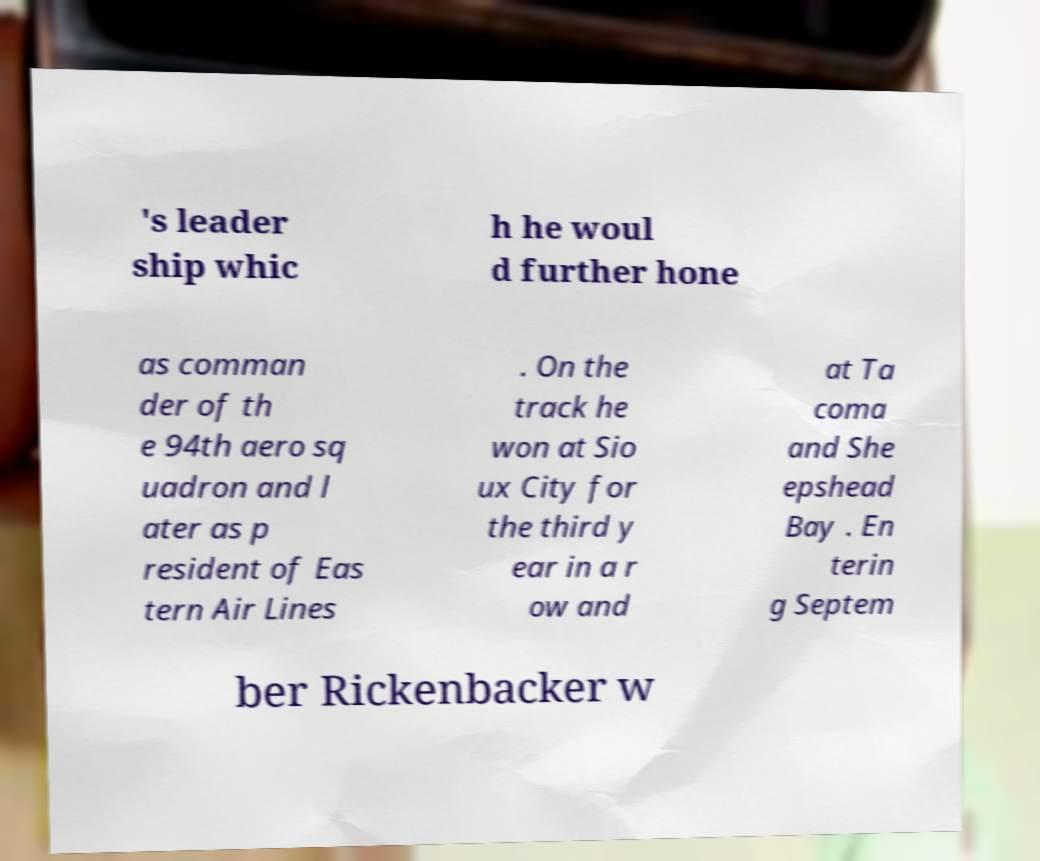For documentation purposes, I need the text within this image transcribed. Could you provide that? 's leader ship whic h he woul d further hone as comman der of th e 94th aero sq uadron and l ater as p resident of Eas tern Air Lines . On the track he won at Sio ux City for the third y ear in a r ow and at Ta coma and She epshead Bay . En terin g Septem ber Rickenbacker w 